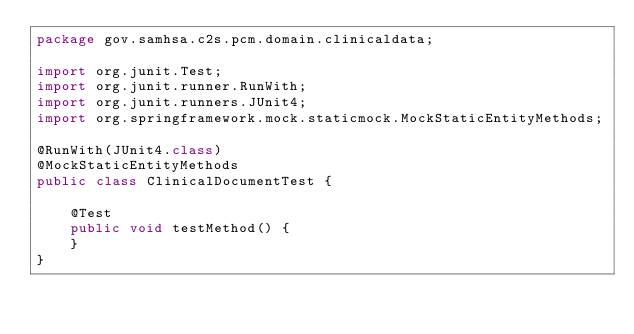<code> <loc_0><loc_0><loc_500><loc_500><_Java_>package gov.samhsa.c2s.pcm.domain.clinicaldata;

import org.junit.Test;
import org.junit.runner.RunWith;
import org.junit.runners.JUnit4;
import org.springframework.mock.staticmock.MockStaticEntityMethods;

@RunWith(JUnit4.class)
@MockStaticEntityMethods
public class ClinicalDocumentTest {

    @Test
    public void testMethod() {
    }
}
</code> 